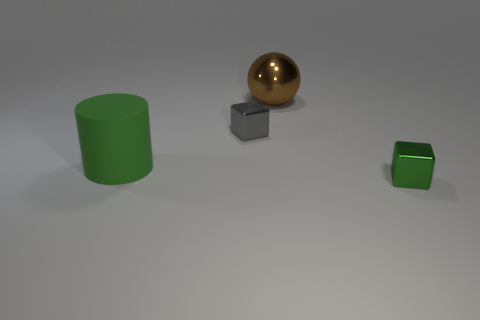Add 4 gray blocks. How many objects exist? 8 Subtract all spheres. How many objects are left? 3 Add 1 large things. How many large things exist? 3 Subtract 0 yellow blocks. How many objects are left? 4 Subtract all small green metallic objects. Subtract all tiny purple things. How many objects are left? 3 Add 2 large brown shiny spheres. How many large brown shiny spheres are left? 3 